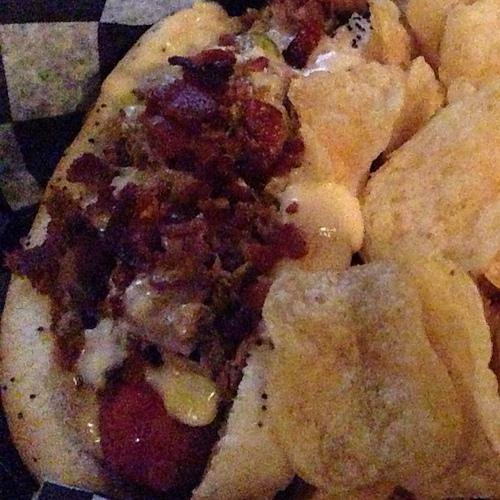Question: what side is served with the hot dog?
Choices:
A. Potato chips.
B. French Fries.
C. Baked Beans.
D. Chili Sauce.
Answer with the letter. Answer: A Question: why is the bun covered in small black beads?
Choices:
A. Seeded Bun.
B. Baked into bun.
C. Poppy seeds.
D. Sesame Seeds.
Answer with the letter. Answer: C Question: what flavor are the chips?
Choices:
A. Plain.
B. Barbeque.
C. Sour Cream and Onion.
D. Salt and Vinegar.
Answer with the letter. Answer: A 